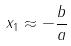<formula> <loc_0><loc_0><loc_500><loc_500>x _ { 1 } \approx - \frac { b } { a }</formula> 